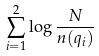<formula> <loc_0><loc_0><loc_500><loc_500>\sum _ { i = 1 } ^ { 2 } \log \frac { N } { n ( q _ { i } ) }</formula> 